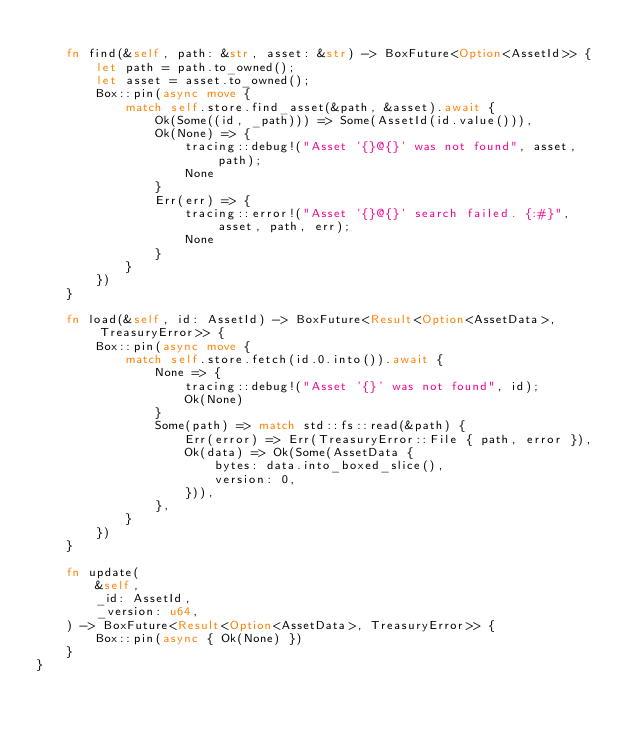<code> <loc_0><loc_0><loc_500><loc_500><_Rust_>
    fn find(&self, path: &str, asset: &str) -> BoxFuture<Option<AssetId>> {
        let path = path.to_owned();
        let asset = asset.to_owned();
        Box::pin(async move {
            match self.store.find_asset(&path, &asset).await {
                Ok(Some((id, _path))) => Some(AssetId(id.value())),
                Ok(None) => {
                    tracing::debug!("Asset '{}@{}' was not found", asset, path);
                    None
                }
                Err(err) => {
                    tracing::error!("Asset '{}@{}' search failed. {:#}", asset, path, err);
                    None
                }
            }
        })
    }

    fn load(&self, id: AssetId) -> BoxFuture<Result<Option<AssetData>, TreasuryError>> {
        Box::pin(async move {
            match self.store.fetch(id.0.into()).await {
                None => {
                    tracing::debug!("Asset '{}' was not found", id);
                    Ok(None)
                }
                Some(path) => match std::fs::read(&path) {
                    Err(error) => Err(TreasuryError::File { path, error }),
                    Ok(data) => Ok(Some(AssetData {
                        bytes: data.into_boxed_slice(),
                        version: 0,
                    })),
                },
            }
        })
    }

    fn update(
        &self,
        _id: AssetId,
        _version: u64,
    ) -> BoxFuture<Result<Option<AssetData>, TreasuryError>> {
        Box::pin(async { Ok(None) })
    }
}
</code> 